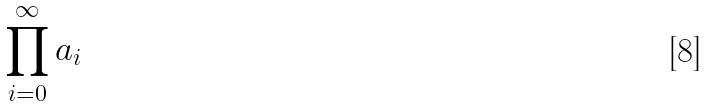<formula> <loc_0><loc_0><loc_500><loc_500>\prod _ { i = 0 } ^ { \infty } a _ { i }</formula> 